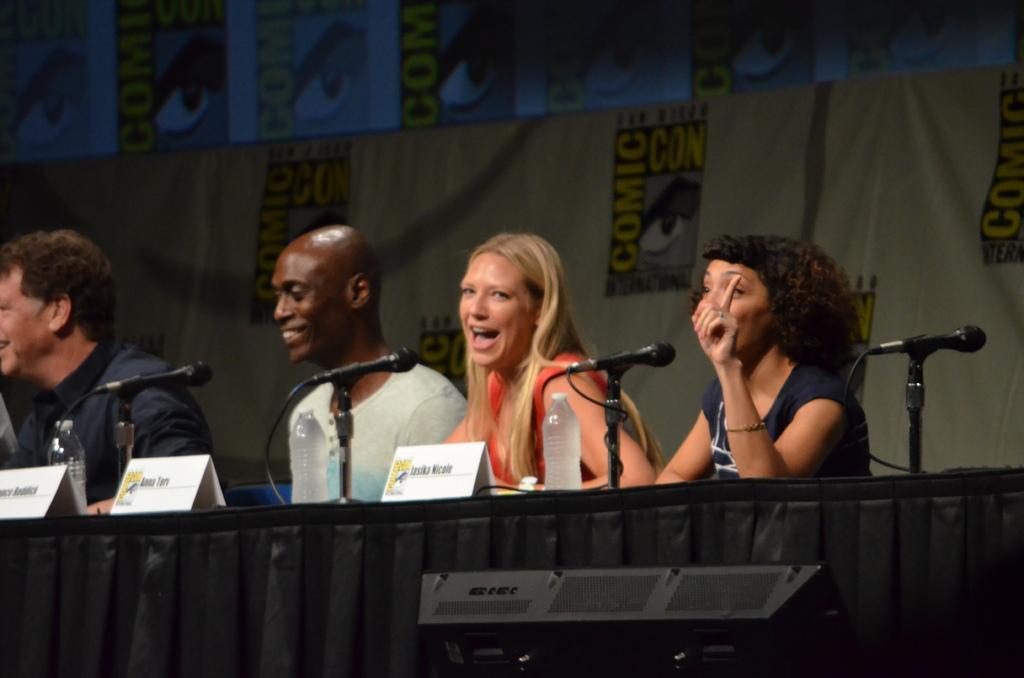Can you describe this image briefly? At the bottom of this image, there is a table on which there are bottles, microphones and name boards arranged. Behind this table, there are two women and two men, smiling. In the background, there is a banner. 